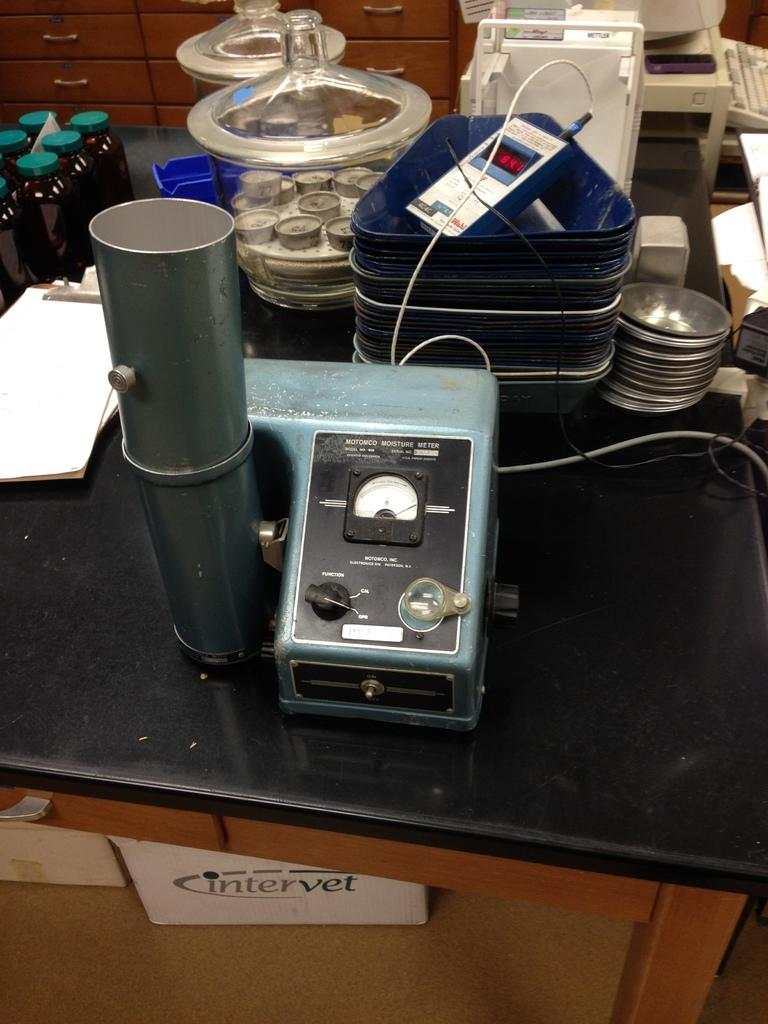Provide a one-sentence caption for the provided image. A black lab bench cluttered with scientific instruments, including a moisture meter. 